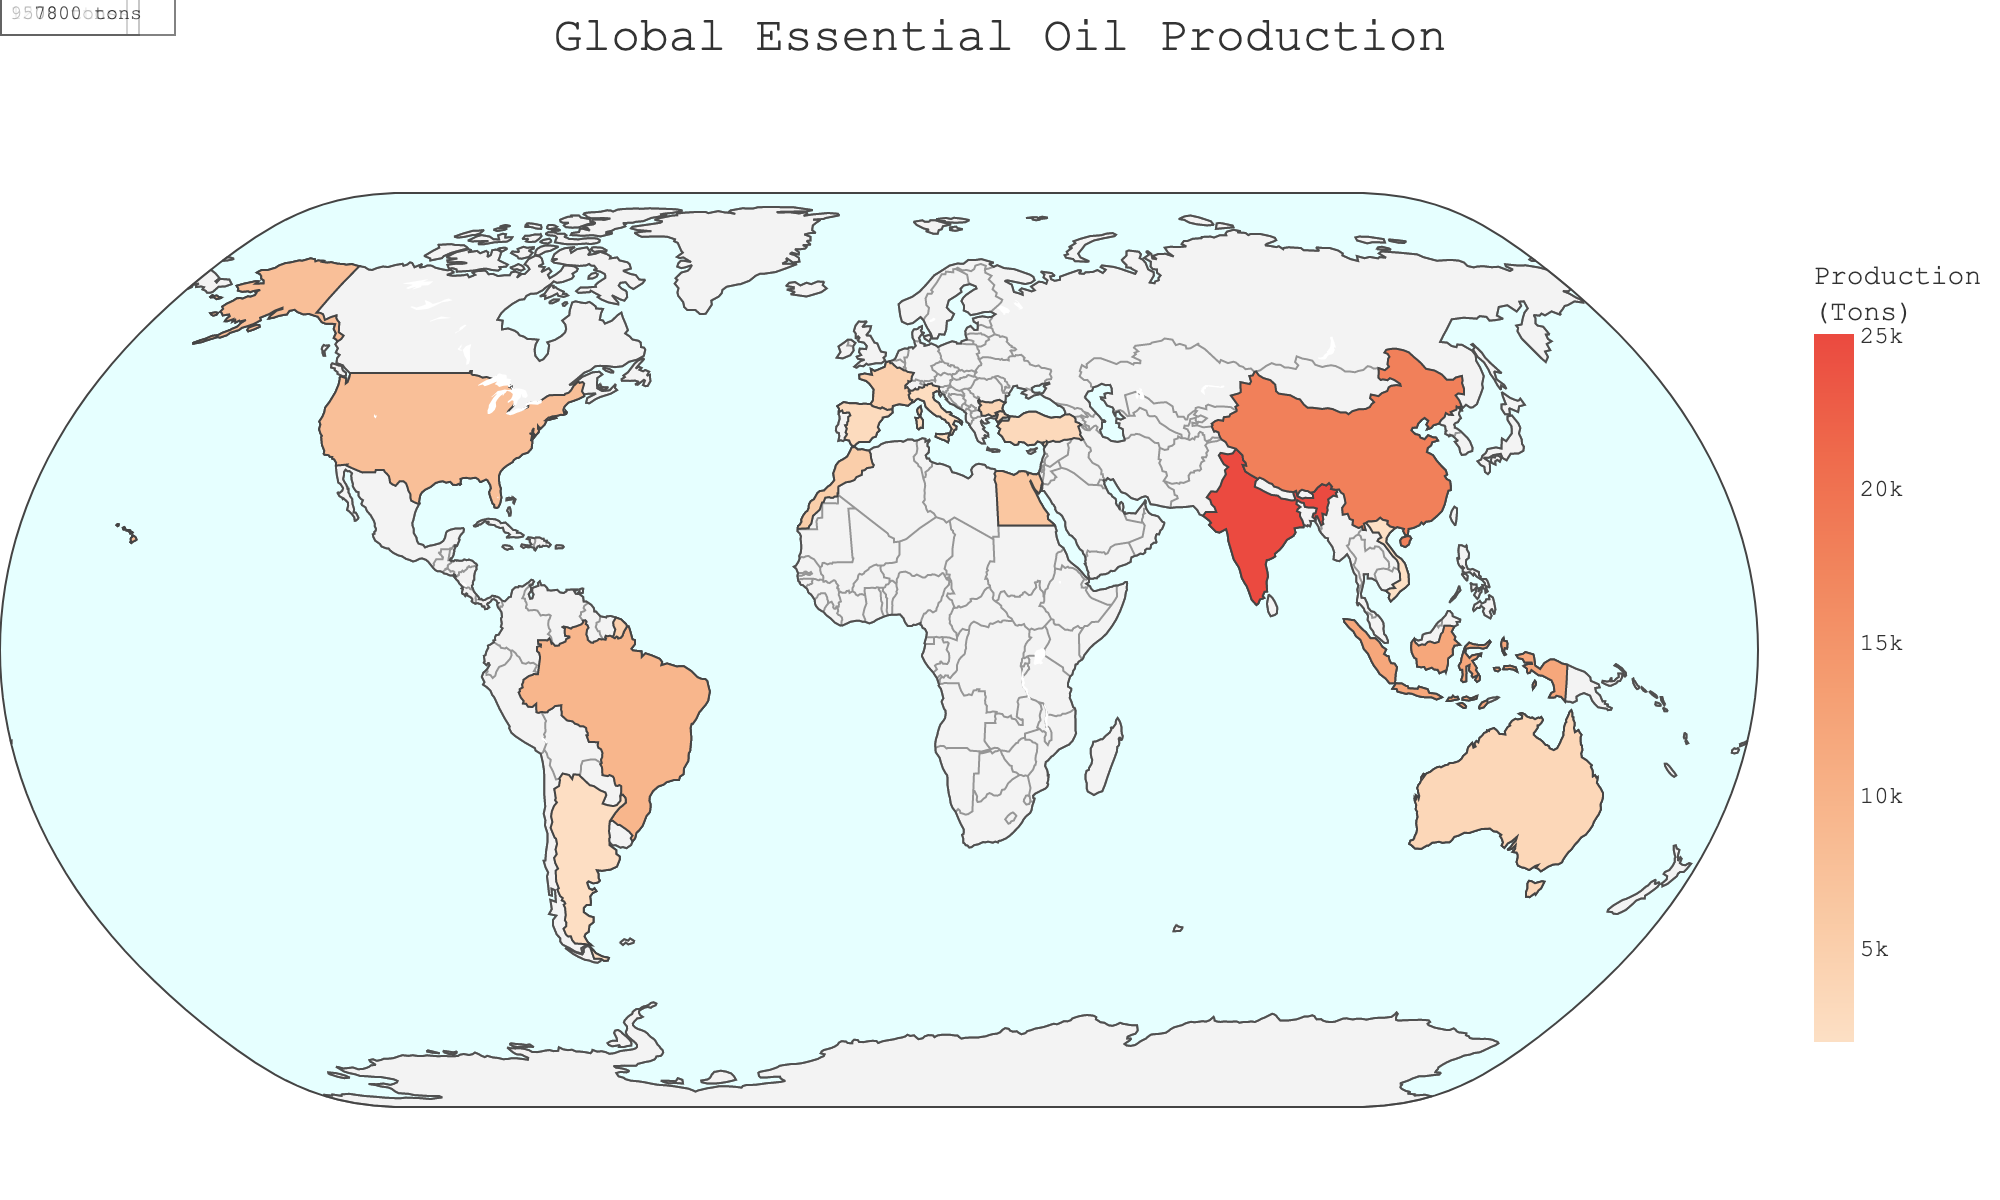What is the title of the figure? The title is prominently displayed at the top of the figure and provides a brief description of what the plot represents.
Answer: Global Essential Oil Production Which country has the highest essential oil production? India is clearly highlighted as the top producer, indicated by the darkest color on the map and an annotation showing the highest production figure.
Answer: India How many tons of essential oil does the second highest producing country produce? China's essential oil production is annotated on the map as the second highest after India.
Answer: 18000 tons What is the combined essential oil production of the top three producing countries? By summing the production figures for India, China, and Indonesia (25000 + 18000 + 12000), we get the total production.
Answer: 61000 tons What is the difference in essential oil production between Brazil and the United States? By subtracting the U.S. production from Brazil's (9500 - 7800), we find the difference.
Answer: 1700 tons Which country produces more essential oil, France or Bulgaria? France is shown to produce more essential oil than Bulgaria based on the color intensity and the annotated production figures.
Answer: France What is the average essential oil production among the top five producers? By summing the production of the top five countries and dividing by five ((25000 + 18000 + 12000 + 9500 + 7800)/5), we get the average production.
Answer: 15660 tons Is Morocco closer in production to Egypt or Turkey? Morocco's production of 5200 tons is closer to Egypt's production of 6500 tons than Turkey's 3200 tons.
Answer: Egypt Which country produces more essential oil, Spain or Turkey? Based on the annotated figures, Spain produces more essential oil than Turkey.
Answer: Spain What can we infer about the geographic distribution of essential oil production? Essential oil production is distributed across various continents with significant contributions from Asia, South America, North America, and Europe, indicating a global industry.
Answer: Global industry 